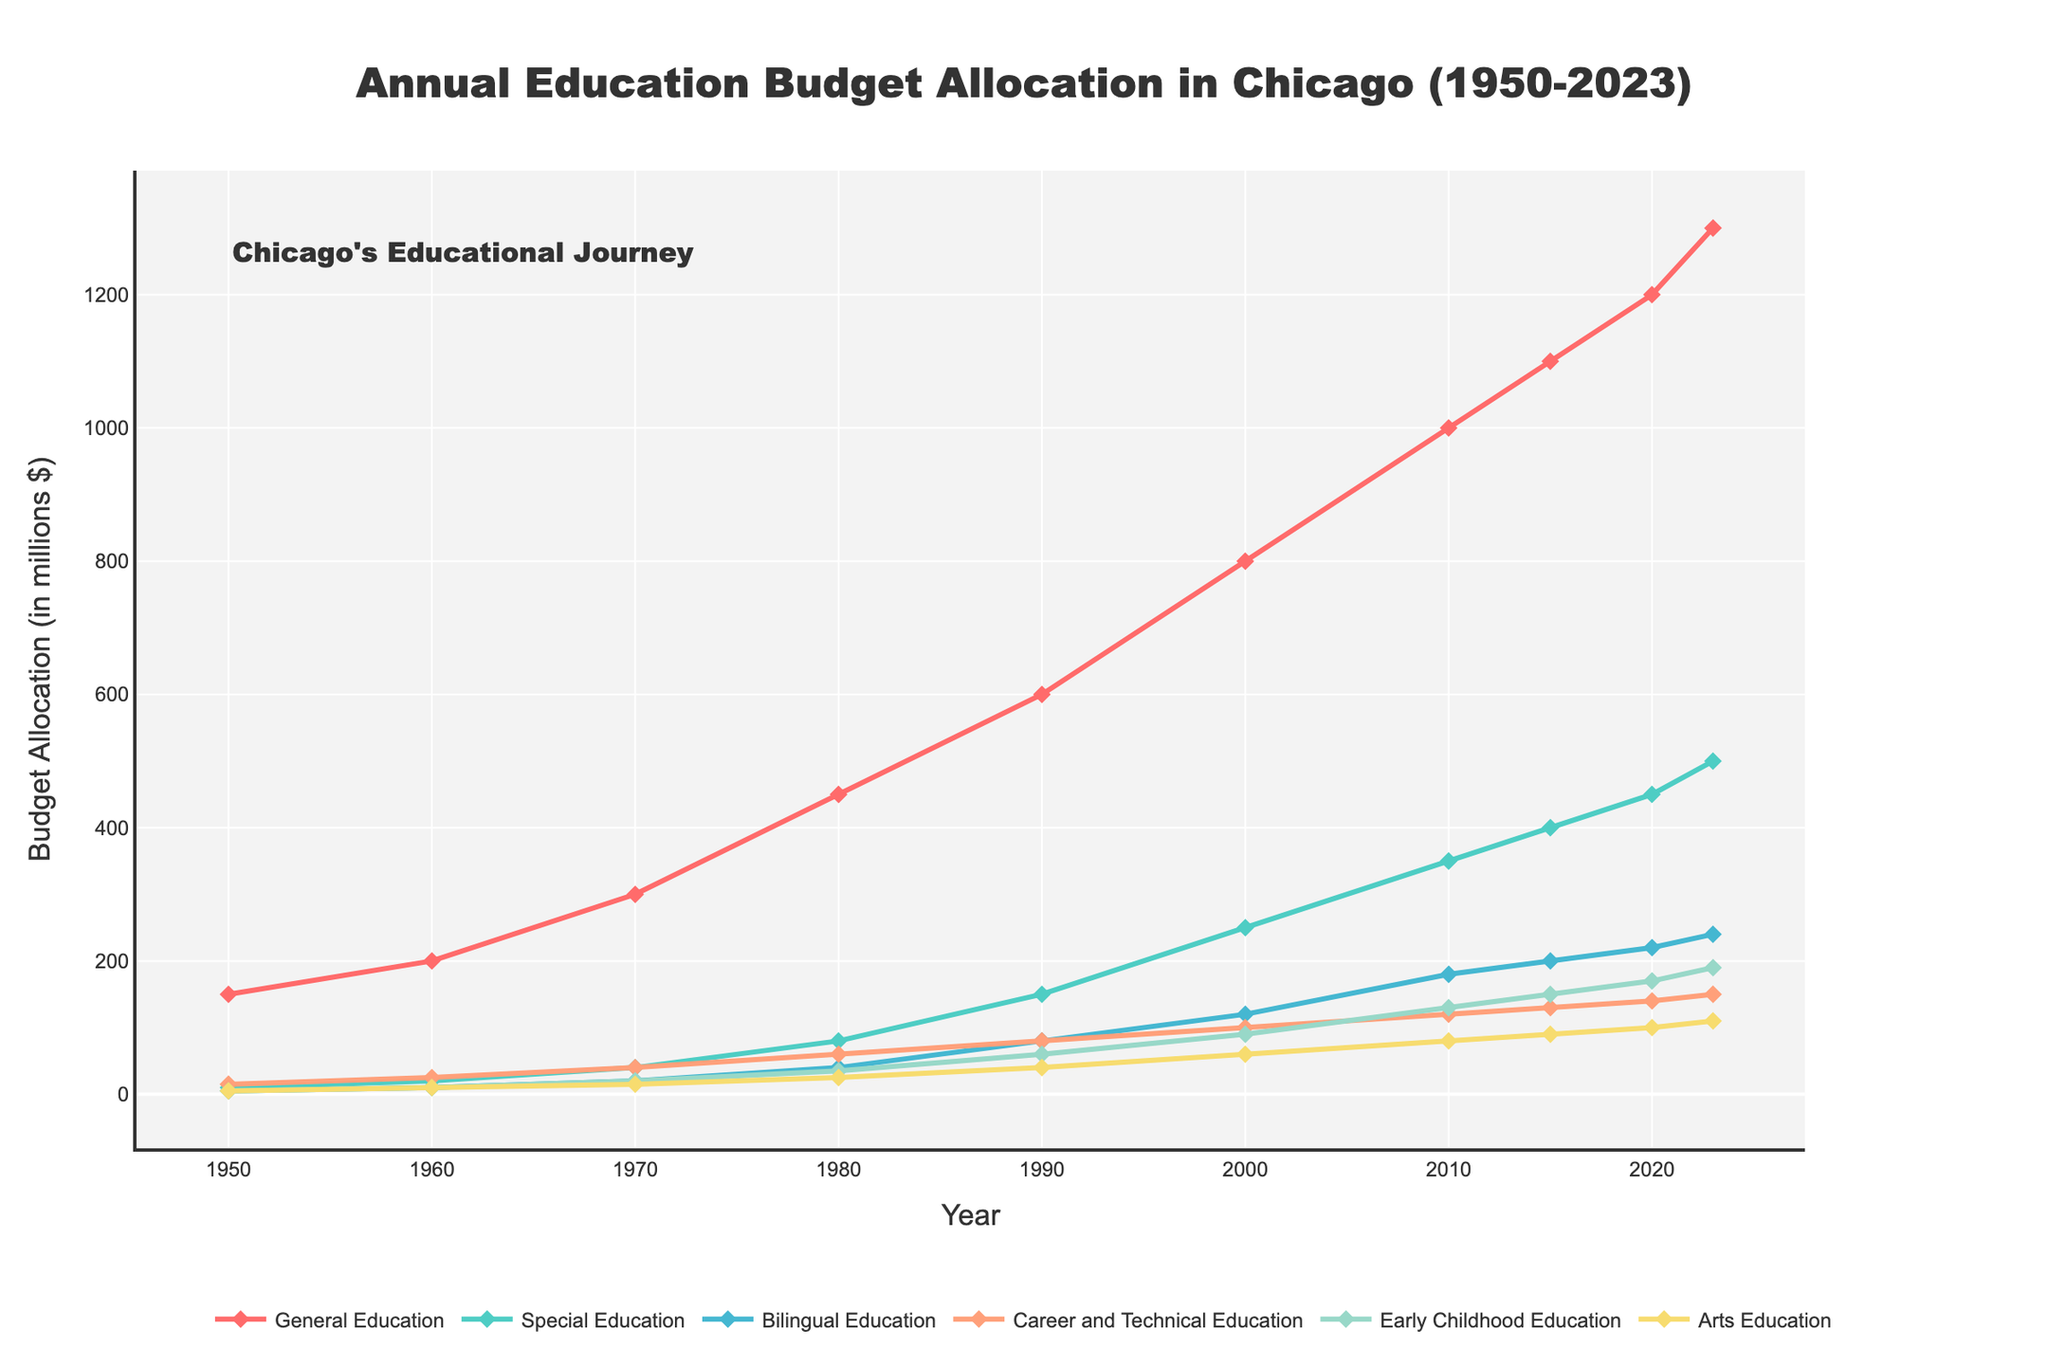what's the total budget allocation for General Education and Special Education in 2023? To find the total budget allocation for General Education and Special Education in 2023, add the values allocated to General Education and Special Education for that year. The values are 1300 (General Education) and 500 (Special Education), so the total is 1300 + 500 = 1800.
Answer: 1800 which educational program experienced the highest increase in budget allocation from 1950 to 2023? To determine which educational program experienced the highest increase in budget allocation from 1950 to 2023, calculate the increase for each program by subtracting the 1950 value from the 2023 value. The programs and their increases are General Education (1300 - 150 = 1150), Special Education (500 - 10 = 490), Bilingual Education (240 - 5 = 235), Career and Technical Education (150 - 15 = 135), Early Childhood Education (190 - 5 = 185), and Arts Education (110 - 5 = 105). General Education has the highest increase (1150).
Answer: General Education how does the budget allocation for Career and Technical Education in 1980 compare to that in 2023? To compare the budget allocation for Career and Technical Education in 1980 vs. 2023, look at their respective values on the chart. In 1980, the allocation was 60, and in 2023, it was 150. The budget in 2023 is larger than in 1980.
Answer: The budget in 2023 is larger what is the difference in budget allocation between Early Childhood Education and Arts Education in 2020? To find the difference between the budget allocations for Early Childhood Education and Arts Education in 2020, subtract the value of Arts Education from Early Childhood Education. The values are 170 (Early Childhood Education) and 100 (Arts Education), so the difference is 170 - 100 = 70.
Answer: 70 in which year did Bilingual Education receive its first significant increase, reaching at least 20 million? To identify the year when Bilingual Education first received at least 20 million, look for the first occurrence of a value equal to or greater than 20 in the Bilingual Education line. This happened in 1970 when the allocation was 20.
Answer: 1970 among the educational programs listed, which one had the least fluctuation in budget allocation over the years shown? To determine which program had the least fluctuation in budget allocation from 1950 to 2023, observe which line shows the smallest overall change on the chart. Bilingual Education has relatively stable increases compared to the others.
Answer: Bilingual Education what is the average budget allocation for Arts Education from 1950 to 2023? To find the average budget allocation for Arts Education, add up the values for all years and divide by the number of years. The values are 5, 10, 15, 25, 40, 60, 80, 90, 100, and 110, which sum up to 535. There are 10 data points, so the average is 535 / 10 = 53.5.
Answer: 53.5 